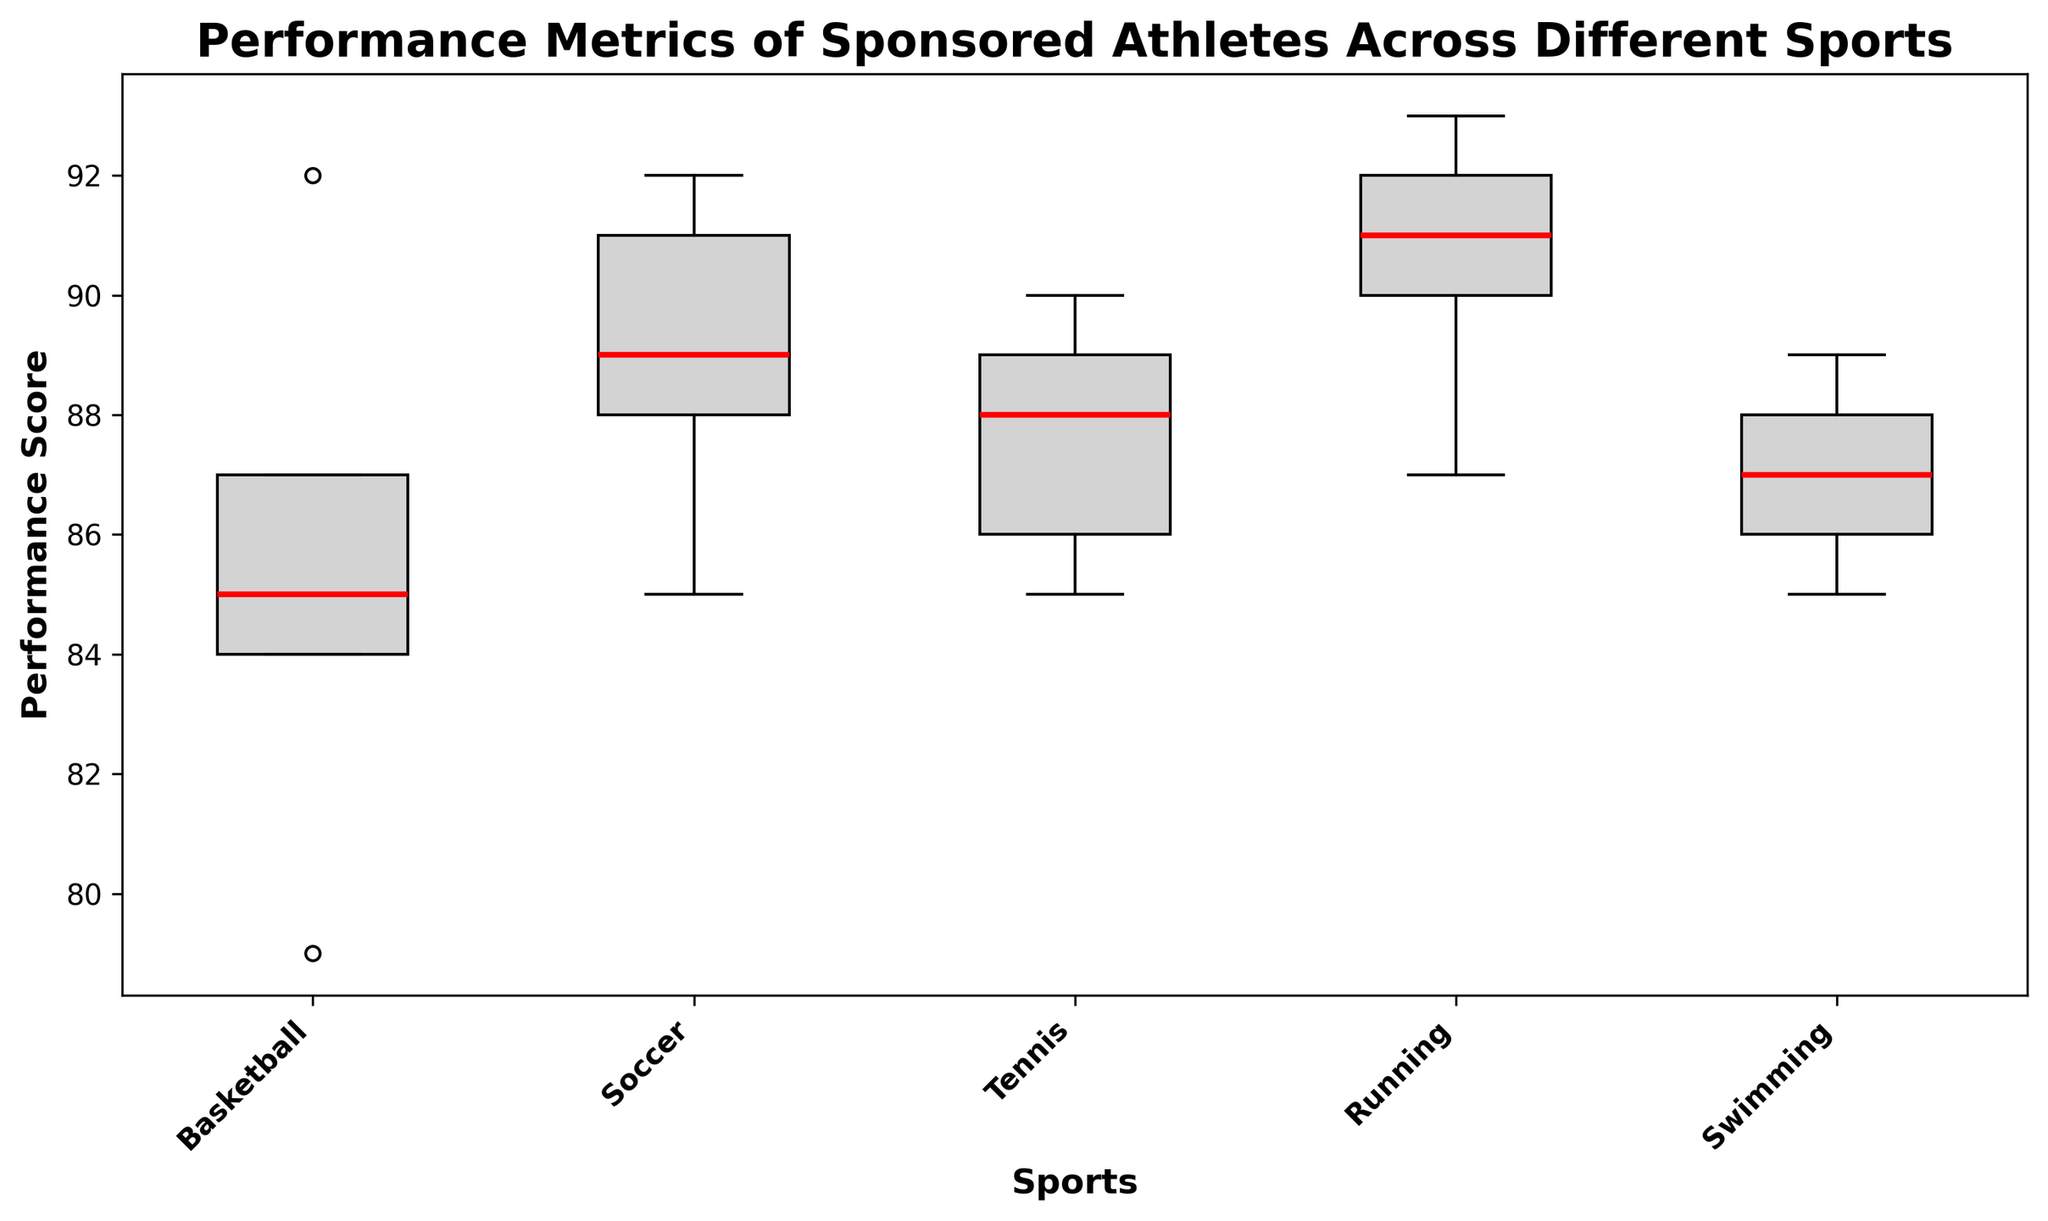Which sport has the highest median performance score? Look at the red median lines in each box plot. The Running box plot has the highest median line.
Answer: Running What is the approximate range of performance scores for Tennis athletes? Identify the minimum and maximum points in the Tennis box plot. The range is from around 85 to 90.
Answer: 85-90 Which sport has the smallest interquartile range (IQR) in performance scores? The IQR is the distance between the 1st quartile and the 3rd quartile. The narrowest box represents the smallest IQR, which is for Swimming.
Answer: Swimming How does the performance score variability of Running compare to Swimming? Compare the spread (whiskers) and the spread of the boxes. Running has larger whiskers and a taller box compared to Swimming, indicating more variability.
Answer: Running has more variability Which sport has a median performance score closest to 88? Look at the red median lines and find the one around 88. Soccer's median line is closest to 88.
Answer: Soccer What's the difference between the median performance scores of Basketball and Soccer? Compare the red median lines for Basketball (approximately 85.5) and Soccer (around 89.5) and calculate the difference.
Answer: 4 Are there any sports with outliers in their performance metrics? If so, which sport(s)? Look for any distinct points outside the whiskers. No obvious outliers are present in any of the sports.
Answer: No Which sport shows the highest maximum performance score? Examine the top whisker ends of all box plots. Running has the highest whisker end, indicating the highest maximum performance score.
Answer: Running What is the median difference between Basketball and Tennis performance scores? Compare the red median lines for Basketball (approximately 85.5) and Tennis (around 88) and calculate the median difference.
Answer: 2.5 Is there an overlap in the performance score ranges of Soccer and Swimming? Compare the whisker ranges of Soccer (about 85 to 92) and Swimming (about 85 to 89). Both ranges share values between 85 and 89, indicating an overlap.
Answer: Yes 